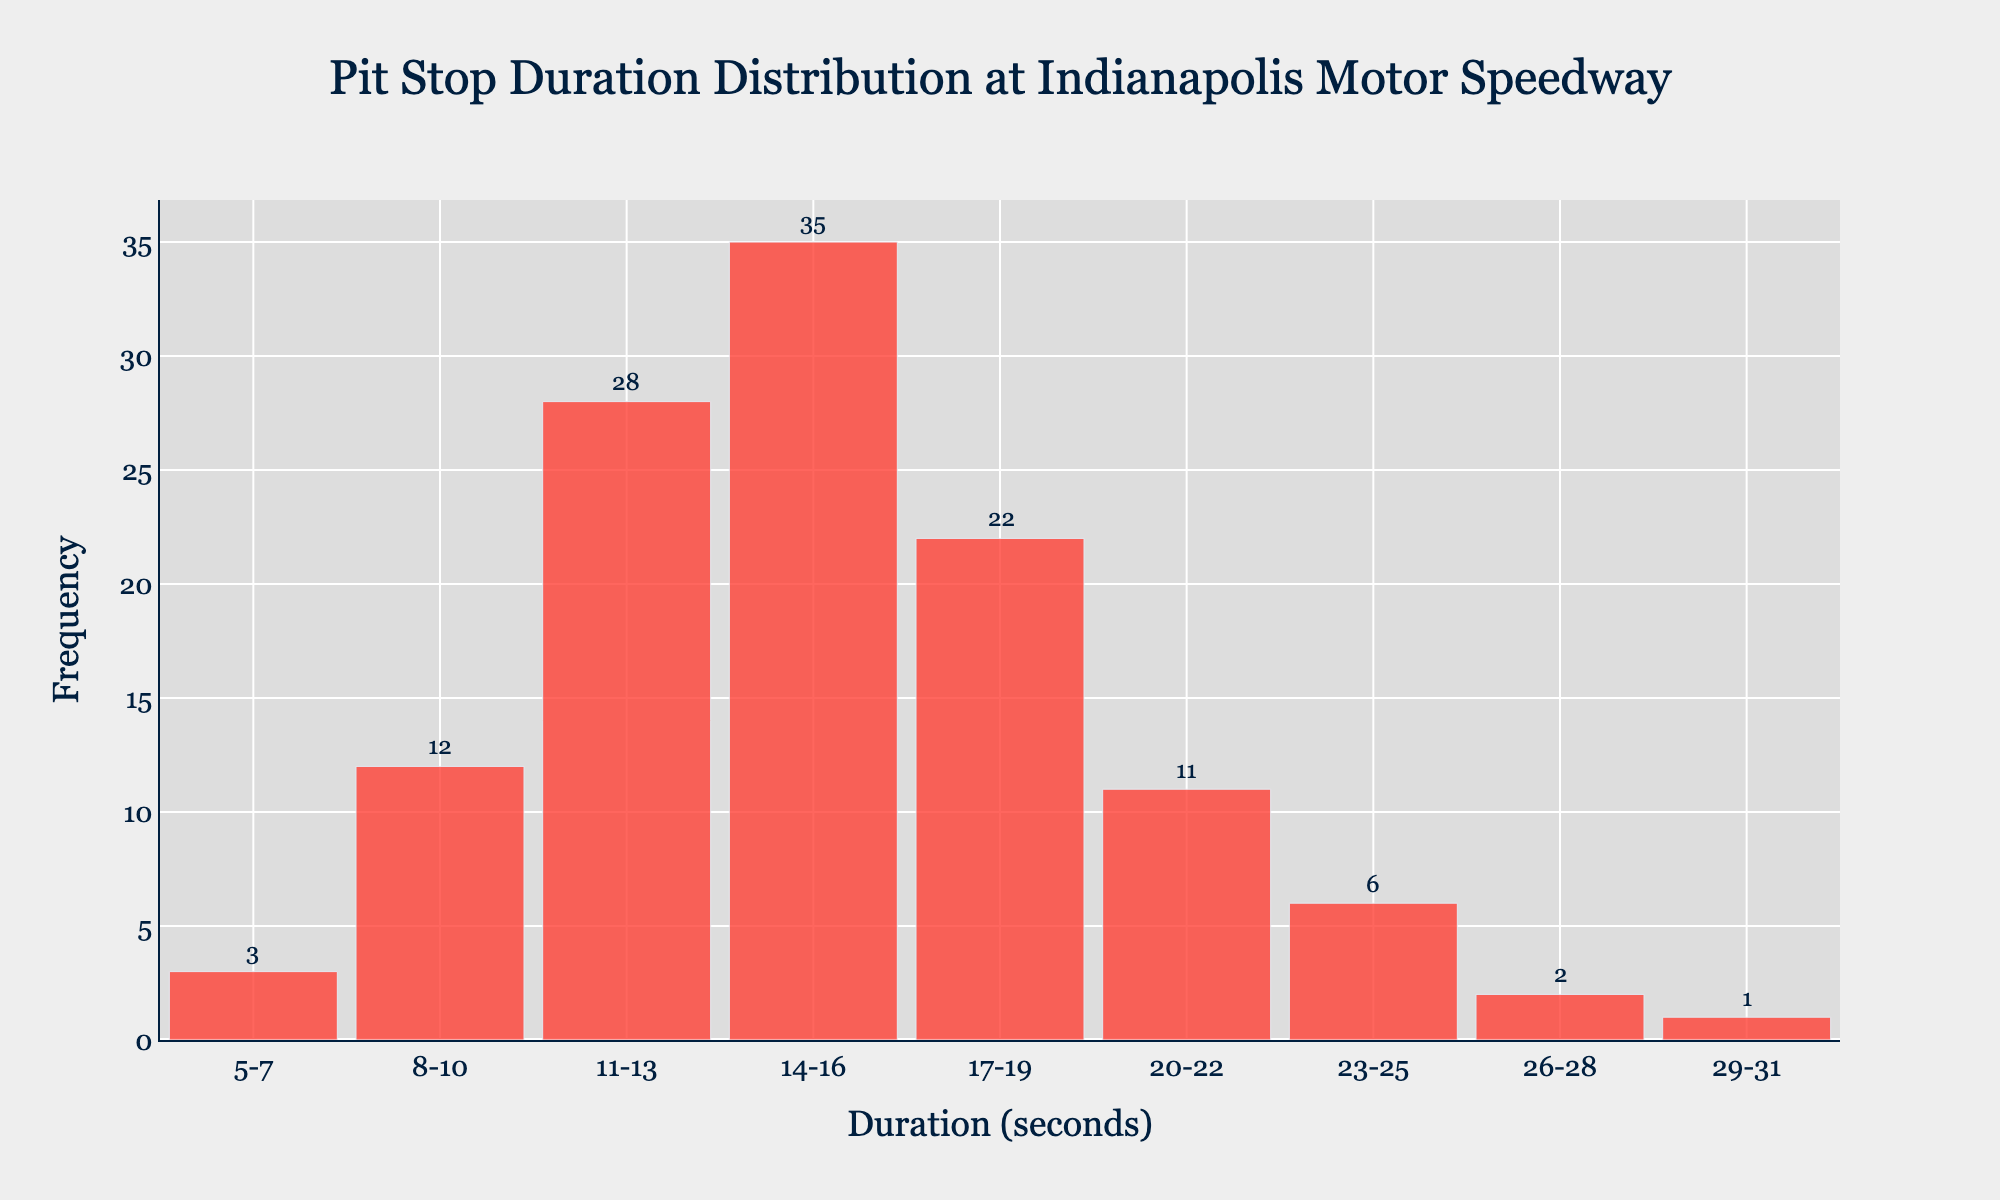What is the title of the histogram? The title of the histogram is located at the top center of the figure. It reads "Pit Stop Duration Distribution at Indianapolis Motor Speedway".
Answer: Pit Stop Duration Distribution at Indianapolis Motor Speedway What is the x-axis label? The x-axis label is displayed below the horizontal axis of the histogram. It indicates what the x-axis represents. It reads "Duration (seconds)".
Answer: Duration (seconds) How many pit stop durations fall within the 14-16 seconds range? To answer this, locate the bar labeled with "14-16 seconds" and note the height of the bar, which also has an annotation specifying the frequency. The annotation on this bar shows the value 35.
Answer: 35 Which duration range has the highest frequency? Look at the heights of all the bars to identify the tallest one. The tallest bar corresponds to the "14-16 seconds" category, which has a frequency of 35.
Answer: 14-16 seconds How many pit stop durations were less than 11 seconds? Identify the frequencies for the duration ranges "5-7", "8-10". Add these two frequencies. They are 3 and 12 respectively. Summing them gives 3 + 12 = 15.
Answer: 15 How many pit stop durations were greater than or equal to 23 seconds? Identify the frequencies for the duration ranges "23-25", "26-28", "29-31". Add these three frequencies. They are 6, 2, and 1 respectively. Summing them gives 6 + 2 + 1 = 9.
Answer: 9 What is the combined frequency of pit stop durations between 8 and 22 seconds? Identify the frequencies for the duration ranges "8-10", "11-13", "14-16", "17-19", "20-22". Add these five frequencies. They are 12, 28, 35, 22, and 11 respectively. Summing them gives 12 + 28 + 35 + 22 + 11 = 108.
Answer: 108 What is the average frequency of the pit stop durations? Sum all the frequencies and divide by the number of duration ranges. The total frequency is 3 + 12 + 28 + 35 + 22 + 11 + 6 + 2 + 1 = 120. There are 9 duration ranges. Thus, the average frequency is 120 / 9 ≈ 13.33.
Answer: 13.33 